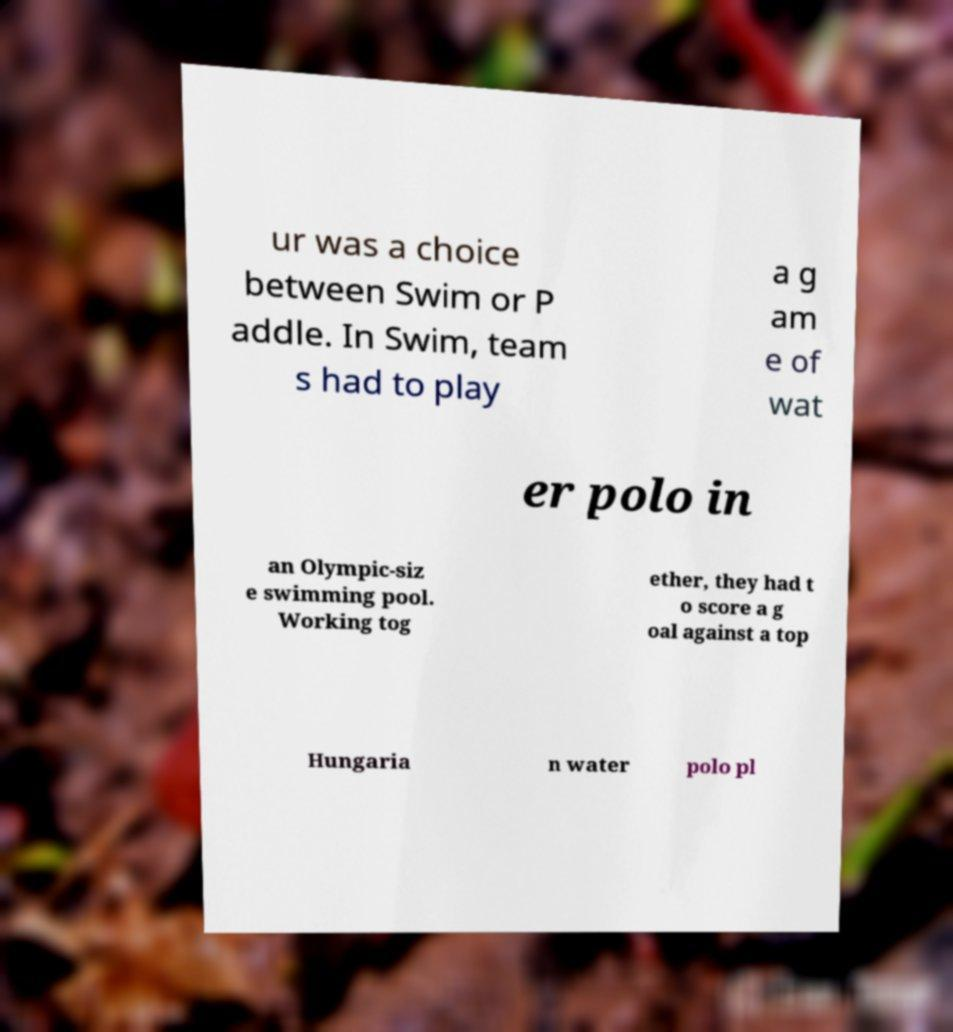Could you extract and type out the text from this image? ur was a choice between Swim or P addle. In Swim, team s had to play a g am e of wat er polo in an Olympic-siz e swimming pool. Working tog ether, they had t o score a g oal against a top Hungaria n water polo pl 